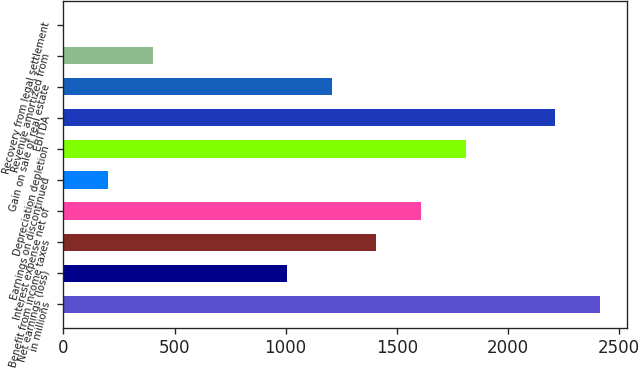Convert chart to OTSL. <chart><loc_0><loc_0><loc_500><loc_500><bar_chart><fcel>in millions<fcel>Net earnings (loss)<fcel>Benefit from income taxes<fcel>Interest expense net of<fcel>Earnings on discontinued<fcel>Depreciation depletion<fcel>EBITDA<fcel>Gain on sale of real estate<fcel>Revenue amortized from<fcel>Recovery from legal settlement<nl><fcel>2414.31<fcel>1006.26<fcel>1408.56<fcel>1609.71<fcel>201.66<fcel>1810.86<fcel>2213.16<fcel>1207.41<fcel>402.81<fcel>0.51<nl></chart> 